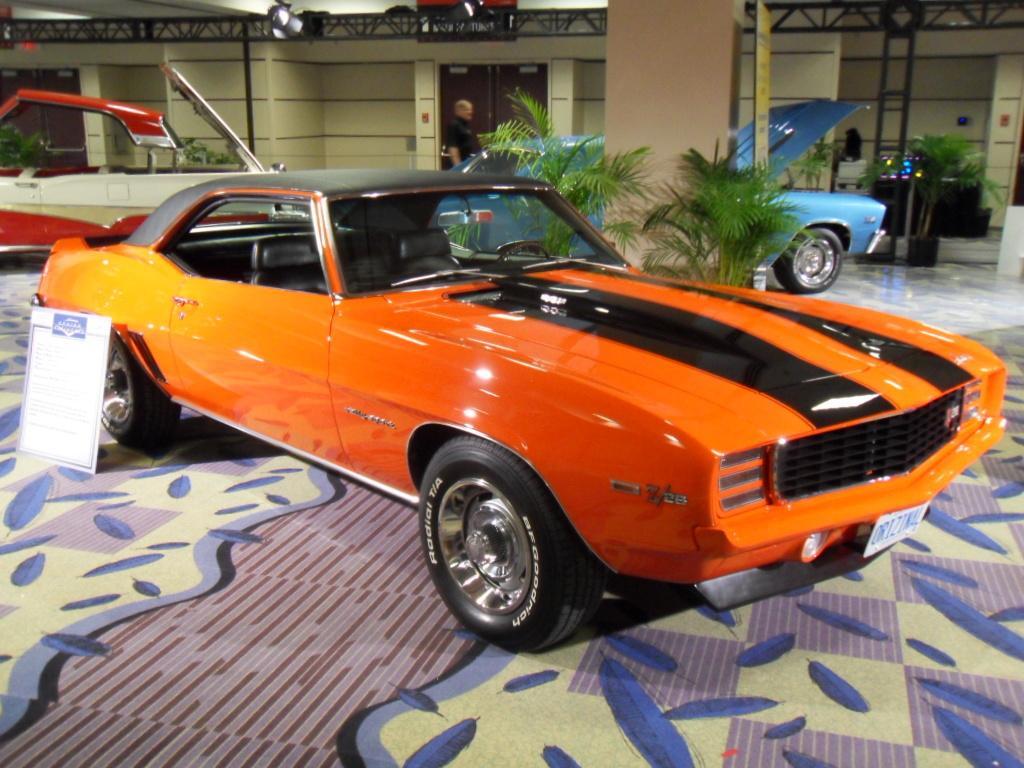Please provide a concise description of this image. In this image there are cars on the floor. At the back side there is a building. In front of the building there is a person standing. 